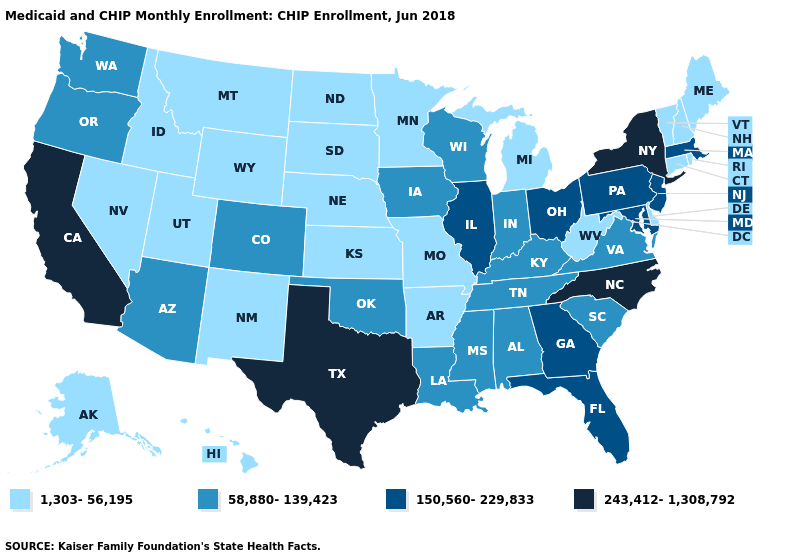Does the first symbol in the legend represent the smallest category?
Concise answer only. Yes. Name the states that have a value in the range 1,303-56,195?
Be succinct. Alaska, Arkansas, Connecticut, Delaware, Hawaii, Idaho, Kansas, Maine, Michigan, Minnesota, Missouri, Montana, Nebraska, Nevada, New Hampshire, New Mexico, North Dakota, Rhode Island, South Dakota, Utah, Vermont, West Virginia, Wyoming. What is the value of Georgia?
Answer briefly. 150,560-229,833. Which states have the lowest value in the USA?
Quick response, please. Alaska, Arkansas, Connecticut, Delaware, Hawaii, Idaho, Kansas, Maine, Michigan, Minnesota, Missouri, Montana, Nebraska, Nevada, New Hampshire, New Mexico, North Dakota, Rhode Island, South Dakota, Utah, Vermont, West Virginia, Wyoming. What is the value of Connecticut?
Concise answer only. 1,303-56,195. Does the first symbol in the legend represent the smallest category?
Be succinct. Yes. Does Kansas have a lower value than Vermont?
Concise answer only. No. Which states have the lowest value in the South?
Be succinct. Arkansas, Delaware, West Virginia. What is the value of New Hampshire?
Concise answer only. 1,303-56,195. What is the highest value in the South ?
Short answer required. 243,412-1,308,792. What is the lowest value in the USA?
Concise answer only. 1,303-56,195. Does Washington have the same value as Montana?
Answer briefly. No. Name the states that have a value in the range 150,560-229,833?
Give a very brief answer. Florida, Georgia, Illinois, Maryland, Massachusetts, New Jersey, Ohio, Pennsylvania. What is the lowest value in states that border Arizona?
Short answer required. 1,303-56,195. Does Illinois have the highest value in the MidWest?
Be succinct. Yes. 